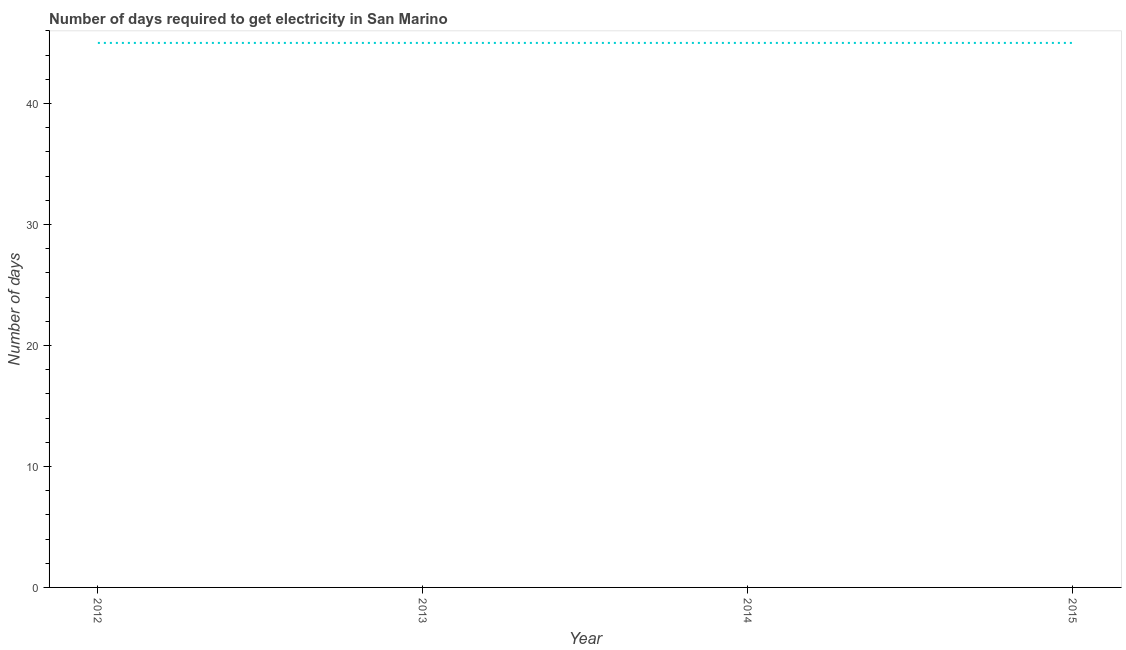What is the time to get electricity in 2014?
Offer a terse response. 45. Across all years, what is the maximum time to get electricity?
Offer a terse response. 45. Across all years, what is the minimum time to get electricity?
Ensure brevity in your answer.  45. What is the sum of the time to get electricity?
Your response must be concise. 180. What is the difference between the time to get electricity in 2014 and 2015?
Your answer should be compact. 0. What is the average time to get electricity per year?
Give a very brief answer. 45. In how many years, is the time to get electricity greater than 30 ?
Your answer should be compact. 4. What is the ratio of the time to get electricity in 2013 to that in 2015?
Your response must be concise. 1. Is the difference between the time to get electricity in 2012 and 2013 greater than the difference between any two years?
Keep it short and to the point. Yes. Is the sum of the time to get electricity in 2013 and 2014 greater than the maximum time to get electricity across all years?
Keep it short and to the point. Yes. How many lines are there?
Your answer should be very brief. 1. How many years are there in the graph?
Give a very brief answer. 4. Are the values on the major ticks of Y-axis written in scientific E-notation?
Your answer should be compact. No. Does the graph contain any zero values?
Your answer should be very brief. No. What is the title of the graph?
Offer a very short reply. Number of days required to get electricity in San Marino. What is the label or title of the X-axis?
Your answer should be very brief. Year. What is the label or title of the Y-axis?
Your answer should be very brief. Number of days. What is the Number of days in 2013?
Keep it short and to the point. 45. What is the Number of days in 2015?
Your response must be concise. 45. What is the difference between the Number of days in 2012 and 2013?
Your answer should be very brief. 0. What is the ratio of the Number of days in 2012 to that in 2013?
Make the answer very short. 1. What is the ratio of the Number of days in 2012 to that in 2014?
Provide a succinct answer. 1. What is the ratio of the Number of days in 2012 to that in 2015?
Provide a short and direct response. 1. What is the ratio of the Number of days in 2013 to that in 2015?
Offer a very short reply. 1. What is the ratio of the Number of days in 2014 to that in 2015?
Keep it short and to the point. 1. 